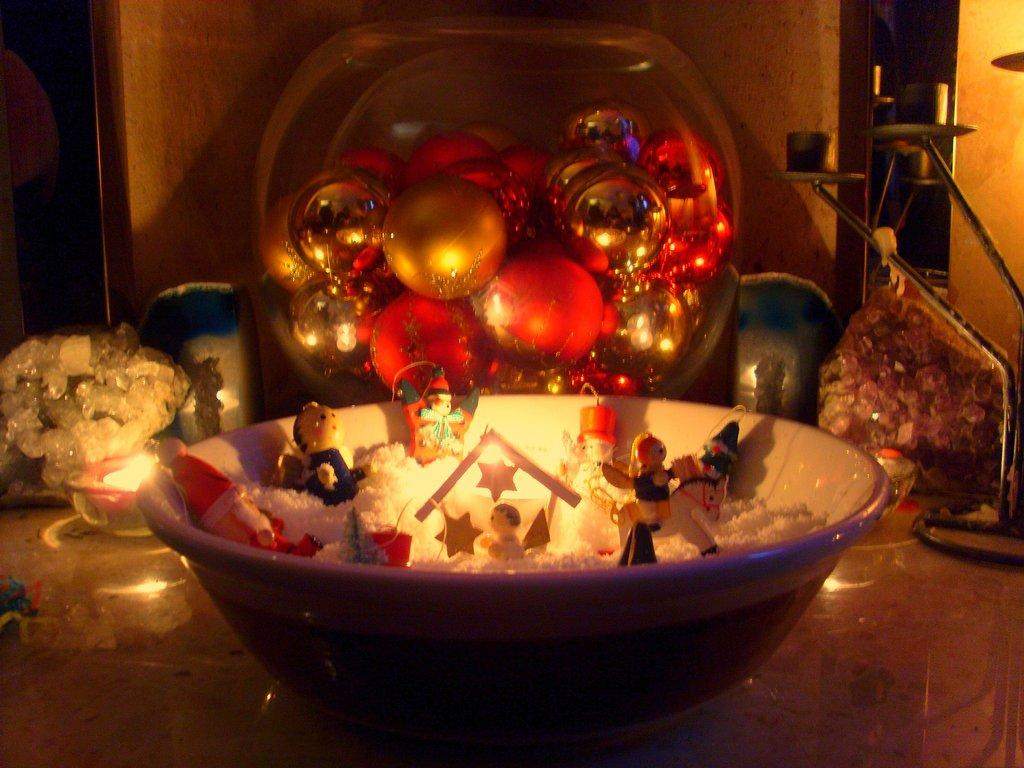What is in the bowl that is visible in the image? There are toys in the bowl in the image. What else can be seen in the image besides the bowl? There are decoration items visible in the background of the image. Can you hear a whistle in the image? There is no whistle present in the image, so it cannot be heard. 